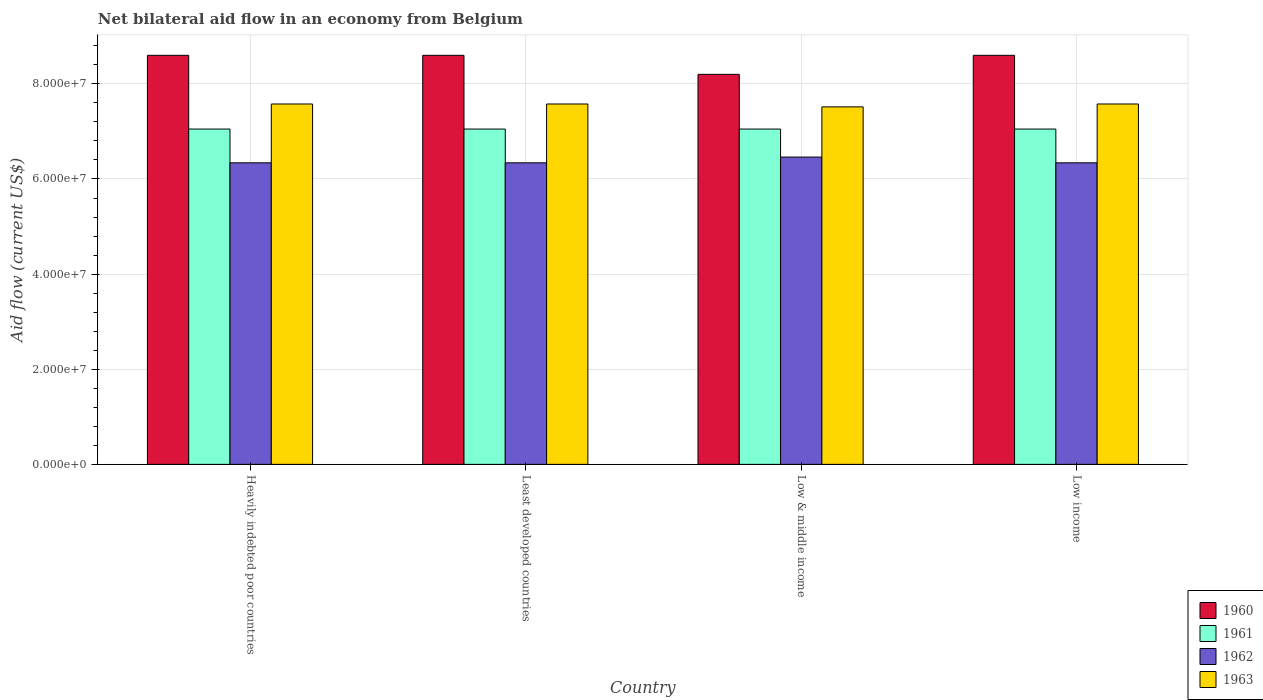How many groups of bars are there?
Keep it short and to the point. 4. Are the number of bars on each tick of the X-axis equal?
Provide a short and direct response. Yes. How many bars are there on the 1st tick from the right?
Provide a succinct answer. 4. What is the label of the 2nd group of bars from the left?
Provide a succinct answer. Least developed countries. What is the net bilateral aid flow in 1962 in Heavily indebted poor countries?
Offer a terse response. 6.34e+07. Across all countries, what is the maximum net bilateral aid flow in 1960?
Your answer should be very brief. 8.60e+07. Across all countries, what is the minimum net bilateral aid flow in 1963?
Make the answer very short. 7.52e+07. In which country was the net bilateral aid flow in 1963 minimum?
Provide a succinct answer. Low & middle income. What is the total net bilateral aid flow in 1962 in the graph?
Offer a very short reply. 2.55e+08. What is the difference between the net bilateral aid flow in 1961 in Low income and the net bilateral aid flow in 1963 in Least developed countries?
Provide a short and direct response. -5.27e+06. What is the average net bilateral aid flow in 1962 per country?
Offer a very short reply. 6.37e+07. What is the difference between the net bilateral aid flow of/in 1962 and net bilateral aid flow of/in 1960 in Low & middle income?
Give a very brief answer. -1.74e+07. Is the net bilateral aid flow in 1963 in Heavily indebted poor countries less than that in Low & middle income?
Offer a very short reply. No. Is the difference between the net bilateral aid flow in 1962 in Low & middle income and Low income greater than the difference between the net bilateral aid flow in 1960 in Low & middle income and Low income?
Offer a very short reply. Yes. What is the difference between the highest and the second highest net bilateral aid flow in 1962?
Your answer should be compact. 1.21e+06. Is it the case that in every country, the sum of the net bilateral aid flow in 1961 and net bilateral aid flow in 1962 is greater than the sum of net bilateral aid flow in 1963 and net bilateral aid flow in 1960?
Provide a succinct answer. No. What does the 2nd bar from the right in Heavily indebted poor countries represents?
Offer a terse response. 1962. Is it the case that in every country, the sum of the net bilateral aid flow in 1960 and net bilateral aid flow in 1961 is greater than the net bilateral aid flow in 1962?
Your response must be concise. Yes. Are all the bars in the graph horizontal?
Your response must be concise. No. Are the values on the major ticks of Y-axis written in scientific E-notation?
Your answer should be very brief. Yes. Does the graph contain grids?
Offer a terse response. Yes. How are the legend labels stacked?
Give a very brief answer. Vertical. What is the title of the graph?
Keep it short and to the point. Net bilateral aid flow in an economy from Belgium. Does "1977" appear as one of the legend labels in the graph?
Provide a short and direct response. No. What is the label or title of the Y-axis?
Provide a short and direct response. Aid flow (current US$). What is the Aid flow (current US$) in 1960 in Heavily indebted poor countries?
Your answer should be very brief. 8.60e+07. What is the Aid flow (current US$) in 1961 in Heavily indebted poor countries?
Give a very brief answer. 7.05e+07. What is the Aid flow (current US$) of 1962 in Heavily indebted poor countries?
Give a very brief answer. 6.34e+07. What is the Aid flow (current US$) in 1963 in Heavily indebted poor countries?
Your answer should be compact. 7.58e+07. What is the Aid flow (current US$) of 1960 in Least developed countries?
Give a very brief answer. 8.60e+07. What is the Aid flow (current US$) in 1961 in Least developed countries?
Provide a succinct answer. 7.05e+07. What is the Aid flow (current US$) in 1962 in Least developed countries?
Keep it short and to the point. 6.34e+07. What is the Aid flow (current US$) in 1963 in Least developed countries?
Ensure brevity in your answer.  7.58e+07. What is the Aid flow (current US$) in 1960 in Low & middle income?
Provide a short and direct response. 8.20e+07. What is the Aid flow (current US$) of 1961 in Low & middle income?
Ensure brevity in your answer.  7.05e+07. What is the Aid flow (current US$) in 1962 in Low & middle income?
Give a very brief answer. 6.46e+07. What is the Aid flow (current US$) of 1963 in Low & middle income?
Provide a short and direct response. 7.52e+07. What is the Aid flow (current US$) of 1960 in Low income?
Your answer should be compact. 8.60e+07. What is the Aid flow (current US$) in 1961 in Low income?
Make the answer very short. 7.05e+07. What is the Aid flow (current US$) in 1962 in Low income?
Provide a succinct answer. 6.34e+07. What is the Aid flow (current US$) of 1963 in Low income?
Ensure brevity in your answer.  7.58e+07. Across all countries, what is the maximum Aid flow (current US$) in 1960?
Your answer should be very brief. 8.60e+07. Across all countries, what is the maximum Aid flow (current US$) of 1961?
Make the answer very short. 7.05e+07. Across all countries, what is the maximum Aid flow (current US$) in 1962?
Make the answer very short. 6.46e+07. Across all countries, what is the maximum Aid flow (current US$) in 1963?
Give a very brief answer. 7.58e+07. Across all countries, what is the minimum Aid flow (current US$) in 1960?
Your answer should be compact. 8.20e+07. Across all countries, what is the minimum Aid flow (current US$) of 1961?
Keep it short and to the point. 7.05e+07. Across all countries, what is the minimum Aid flow (current US$) of 1962?
Your answer should be very brief. 6.34e+07. Across all countries, what is the minimum Aid flow (current US$) of 1963?
Your response must be concise. 7.52e+07. What is the total Aid flow (current US$) of 1960 in the graph?
Your response must be concise. 3.40e+08. What is the total Aid flow (current US$) in 1961 in the graph?
Make the answer very short. 2.82e+08. What is the total Aid flow (current US$) of 1962 in the graph?
Give a very brief answer. 2.55e+08. What is the total Aid flow (current US$) in 1963 in the graph?
Ensure brevity in your answer.  3.02e+08. What is the difference between the Aid flow (current US$) in 1961 in Heavily indebted poor countries and that in Least developed countries?
Provide a succinct answer. 0. What is the difference between the Aid flow (current US$) of 1962 in Heavily indebted poor countries and that in Least developed countries?
Your answer should be compact. 0. What is the difference between the Aid flow (current US$) in 1960 in Heavily indebted poor countries and that in Low & middle income?
Ensure brevity in your answer.  4.00e+06. What is the difference between the Aid flow (current US$) in 1962 in Heavily indebted poor countries and that in Low & middle income?
Give a very brief answer. -1.21e+06. What is the difference between the Aid flow (current US$) of 1963 in Heavily indebted poor countries and that in Low & middle income?
Keep it short and to the point. 6.10e+05. What is the difference between the Aid flow (current US$) in 1960 in Heavily indebted poor countries and that in Low income?
Provide a short and direct response. 0. What is the difference between the Aid flow (current US$) of 1963 in Heavily indebted poor countries and that in Low income?
Keep it short and to the point. 0. What is the difference between the Aid flow (current US$) of 1960 in Least developed countries and that in Low & middle income?
Keep it short and to the point. 4.00e+06. What is the difference between the Aid flow (current US$) of 1961 in Least developed countries and that in Low & middle income?
Give a very brief answer. 0. What is the difference between the Aid flow (current US$) of 1962 in Least developed countries and that in Low & middle income?
Offer a terse response. -1.21e+06. What is the difference between the Aid flow (current US$) in 1963 in Least developed countries and that in Low & middle income?
Keep it short and to the point. 6.10e+05. What is the difference between the Aid flow (current US$) in 1962 in Least developed countries and that in Low income?
Your response must be concise. 0. What is the difference between the Aid flow (current US$) in 1961 in Low & middle income and that in Low income?
Keep it short and to the point. 0. What is the difference between the Aid flow (current US$) in 1962 in Low & middle income and that in Low income?
Offer a terse response. 1.21e+06. What is the difference between the Aid flow (current US$) of 1963 in Low & middle income and that in Low income?
Keep it short and to the point. -6.10e+05. What is the difference between the Aid flow (current US$) of 1960 in Heavily indebted poor countries and the Aid flow (current US$) of 1961 in Least developed countries?
Provide a short and direct response. 1.55e+07. What is the difference between the Aid flow (current US$) in 1960 in Heavily indebted poor countries and the Aid flow (current US$) in 1962 in Least developed countries?
Provide a short and direct response. 2.26e+07. What is the difference between the Aid flow (current US$) in 1960 in Heavily indebted poor countries and the Aid flow (current US$) in 1963 in Least developed countries?
Your response must be concise. 1.02e+07. What is the difference between the Aid flow (current US$) in 1961 in Heavily indebted poor countries and the Aid flow (current US$) in 1962 in Least developed countries?
Make the answer very short. 7.10e+06. What is the difference between the Aid flow (current US$) of 1961 in Heavily indebted poor countries and the Aid flow (current US$) of 1963 in Least developed countries?
Provide a succinct answer. -5.27e+06. What is the difference between the Aid flow (current US$) of 1962 in Heavily indebted poor countries and the Aid flow (current US$) of 1963 in Least developed countries?
Provide a short and direct response. -1.24e+07. What is the difference between the Aid flow (current US$) of 1960 in Heavily indebted poor countries and the Aid flow (current US$) of 1961 in Low & middle income?
Offer a very short reply. 1.55e+07. What is the difference between the Aid flow (current US$) in 1960 in Heavily indebted poor countries and the Aid flow (current US$) in 1962 in Low & middle income?
Make the answer very short. 2.14e+07. What is the difference between the Aid flow (current US$) of 1960 in Heavily indebted poor countries and the Aid flow (current US$) of 1963 in Low & middle income?
Provide a short and direct response. 1.08e+07. What is the difference between the Aid flow (current US$) of 1961 in Heavily indebted poor countries and the Aid flow (current US$) of 1962 in Low & middle income?
Make the answer very short. 5.89e+06. What is the difference between the Aid flow (current US$) of 1961 in Heavily indebted poor countries and the Aid flow (current US$) of 1963 in Low & middle income?
Make the answer very short. -4.66e+06. What is the difference between the Aid flow (current US$) in 1962 in Heavily indebted poor countries and the Aid flow (current US$) in 1963 in Low & middle income?
Provide a succinct answer. -1.18e+07. What is the difference between the Aid flow (current US$) of 1960 in Heavily indebted poor countries and the Aid flow (current US$) of 1961 in Low income?
Keep it short and to the point. 1.55e+07. What is the difference between the Aid flow (current US$) of 1960 in Heavily indebted poor countries and the Aid flow (current US$) of 1962 in Low income?
Your answer should be very brief. 2.26e+07. What is the difference between the Aid flow (current US$) in 1960 in Heavily indebted poor countries and the Aid flow (current US$) in 1963 in Low income?
Your response must be concise. 1.02e+07. What is the difference between the Aid flow (current US$) in 1961 in Heavily indebted poor countries and the Aid flow (current US$) in 1962 in Low income?
Ensure brevity in your answer.  7.10e+06. What is the difference between the Aid flow (current US$) of 1961 in Heavily indebted poor countries and the Aid flow (current US$) of 1963 in Low income?
Provide a succinct answer. -5.27e+06. What is the difference between the Aid flow (current US$) in 1962 in Heavily indebted poor countries and the Aid flow (current US$) in 1963 in Low income?
Provide a succinct answer. -1.24e+07. What is the difference between the Aid flow (current US$) of 1960 in Least developed countries and the Aid flow (current US$) of 1961 in Low & middle income?
Keep it short and to the point. 1.55e+07. What is the difference between the Aid flow (current US$) of 1960 in Least developed countries and the Aid flow (current US$) of 1962 in Low & middle income?
Offer a terse response. 2.14e+07. What is the difference between the Aid flow (current US$) of 1960 in Least developed countries and the Aid flow (current US$) of 1963 in Low & middle income?
Offer a very short reply. 1.08e+07. What is the difference between the Aid flow (current US$) of 1961 in Least developed countries and the Aid flow (current US$) of 1962 in Low & middle income?
Keep it short and to the point. 5.89e+06. What is the difference between the Aid flow (current US$) of 1961 in Least developed countries and the Aid flow (current US$) of 1963 in Low & middle income?
Give a very brief answer. -4.66e+06. What is the difference between the Aid flow (current US$) in 1962 in Least developed countries and the Aid flow (current US$) in 1963 in Low & middle income?
Provide a short and direct response. -1.18e+07. What is the difference between the Aid flow (current US$) of 1960 in Least developed countries and the Aid flow (current US$) of 1961 in Low income?
Offer a very short reply. 1.55e+07. What is the difference between the Aid flow (current US$) of 1960 in Least developed countries and the Aid flow (current US$) of 1962 in Low income?
Your answer should be very brief. 2.26e+07. What is the difference between the Aid flow (current US$) of 1960 in Least developed countries and the Aid flow (current US$) of 1963 in Low income?
Offer a terse response. 1.02e+07. What is the difference between the Aid flow (current US$) in 1961 in Least developed countries and the Aid flow (current US$) in 1962 in Low income?
Keep it short and to the point. 7.10e+06. What is the difference between the Aid flow (current US$) in 1961 in Least developed countries and the Aid flow (current US$) in 1963 in Low income?
Ensure brevity in your answer.  -5.27e+06. What is the difference between the Aid flow (current US$) in 1962 in Least developed countries and the Aid flow (current US$) in 1963 in Low income?
Offer a terse response. -1.24e+07. What is the difference between the Aid flow (current US$) in 1960 in Low & middle income and the Aid flow (current US$) in 1961 in Low income?
Provide a short and direct response. 1.15e+07. What is the difference between the Aid flow (current US$) in 1960 in Low & middle income and the Aid flow (current US$) in 1962 in Low income?
Give a very brief answer. 1.86e+07. What is the difference between the Aid flow (current US$) of 1960 in Low & middle income and the Aid flow (current US$) of 1963 in Low income?
Keep it short and to the point. 6.23e+06. What is the difference between the Aid flow (current US$) in 1961 in Low & middle income and the Aid flow (current US$) in 1962 in Low income?
Provide a short and direct response. 7.10e+06. What is the difference between the Aid flow (current US$) in 1961 in Low & middle income and the Aid flow (current US$) in 1963 in Low income?
Your answer should be very brief. -5.27e+06. What is the difference between the Aid flow (current US$) of 1962 in Low & middle income and the Aid flow (current US$) of 1963 in Low income?
Offer a very short reply. -1.12e+07. What is the average Aid flow (current US$) in 1960 per country?
Provide a succinct answer. 8.50e+07. What is the average Aid flow (current US$) of 1961 per country?
Your answer should be compact. 7.05e+07. What is the average Aid flow (current US$) of 1962 per country?
Provide a succinct answer. 6.37e+07. What is the average Aid flow (current US$) in 1963 per country?
Your response must be concise. 7.56e+07. What is the difference between the Aid flow (current US$) in 1960 and Aid flow (current US$) in 1961 in Heavily indebted poor countries?
Keep it short and to the point. 1.55e+07. What is the difference between the Aid flow (current US$) in 1960 and Aid flow (current US$) in 1962 in Heavily indebted poor countries?
Your answer should be compact. 2.26e+07. What is the difference between the Aid flow (current US$) of 1960 and Aid flow (current US$) of 1963 in Heavily indebted poor countries?
Your answer should be compact. 1.02e+07. What is the difference between the Aid flow (current US$) of 1961 and Aid flow (current US$) of 1962 in Heavily indebted poor countries?
Offer a terse response. 7.10e+06. What is the difference between the Aid flow (current US$) in 1961 and Aid flow (current US$) in 1963 in Heavily indebted poor countries?
Make the answer very short. -5.27e+06. What is the difference between the Aid flow (current US$) in 1962 and Aid flow (current US$) in 1963 in Heavily indebted poor countries?
Offer a terse response. -1.24e+07. What is the difference between the Aid flow (current US$) of 1960 and Aid flow (current US$) of 1961 in Least developed countries?
Keep it short and to the point. 1.55e+07. What is the difference between the Aid flow (current US$) in 1960 and Aid flow (current US$) in 1962 in Least developed countries?
Your answer should be compact. 2.26e+07. What is the difference between the Aid flow (current US$) of 1960 and Aid flow (current US$) of 1963 in Least developed countries?
Offer a very short reply. 1.02e+07. What is the difference between the Aid flow (current US$) of 1961 and Aid flow (current US$) of 1962 in Least developed countries?
Offer a very short reply. 7.10e+06. What is the difference between the Aid flow (current US$) in 1961 and Aid flow (current US$) in 1963 in Least developed countries?
Keep it short and to the point. -5.27e+06. What is the difference between the Aid flow (current US$) of 1962 and Aid flow (current US$) of 1963 in Least developed countries?
Offer a terse response. -1.24e+07. What is the difference between the Aid flow (current US$) in 1960 and Aid flow (current US$) in 1961 in Low & middle income?
Ensure brevity in your answer.  1.15e+07. What is the difference between the Aid flow (current US$) in 1960 and Aid flow (current US$) in 1962 in Low & middle income?
Offer a terse response. 1.74e+07. What is the difference between the Aid flow (current US$) in 1960 and Aid flow (current US$) in 1963 in Low & middle income?
Keep it short and to the point. 6.84e+06. What is the difference between the Aid flow (current US$) of 1961 and Aid flow (current US$) of 1962 in Low & middle income?
Provide a succinct answer. 5.89e+06. What is the difference between the Aid flow (current US$) of 1961 and Aid flow (current US$) of 1963 in Low & middle income?
Ensure brevity in your answer.  -4.66e+06. What is the difference between the Aid flow (current US$) of 1962 and Aid flow (current US$) of 1963 in Low & middle income?
Your answer should be compact. -1.06e+07. What is the difference between the Aid flow (current US$) of 1960 and Aid flow (current US$) of 1961 in Low income?
Keep it short and to the point. 1.55e+07. What is the difference between the Aid flow (current US$) in 1960 and Aid flow (current US$) in 1962 in Low income?
Give a very brief answer. 2.26e+07. What is the difference between the Aid flow (current US$) of 1960 and Aid flow (current US$) of 1963 in Low income?
Ensure brevity in your answer.  1.02e+07. What is the difference between the Aid flow (current US$) in 1961 and Aid flow (current US$) in 1962 in Low income?
Your answer should be compact. 7.10e+06. What is the difference between the Aid flow (current US$) in 1961 and Aid flow (current US$) in 1963 in Low income?
Provide a succinct answer. -5.27e+06. What is the difference between the Aid flow (current US$) in 1962 and Aid flow (current US$) in 1963 in Low income?
Ensure brevity in your answer.  -1.24e+07. What is the ratio of the Aid flow (current US$) in 1962 in Heavily indebted poor countries to that in Least developed countries?
Keep it short and to the point. 1. What is the ratio of the Aid flow (current US$) of 1960 in Heavily indebted poor countries to that in Low & middle income?
Provide a short and direct response. 1.05. What is the ratio of the Aid flow (current US$) of 1962 in Heavily indebted poor countries to that in Low & middle income?
Ensure brevity in your answer.  0.98. What is the ratio of the Aid flow (current US$) in 1963 in Heavily indebted poor countries to that in Low & middle income?
Provide a succinct answer. 1.01. What is the ratio of the Aid flow (current US$) in 1960 in Heavily indebted poor countries to that in Low income?
Your answer should be very brief. 1. What is the ratio of the Aid flow (current US$) of 1963 in Heavily indebted poor countries to that in Low income?
Your answer should be compact. 1. What is the ratio of the Aid flow (current US$) of 1960 in Least developed countries to that in Low & middle income?
Give a very brief answer. 1.05. What is the ratio of the Aid flow (current US$) of 1961 in Least developed countries to that in Low & middle income?
Your answer should be very brief. 1. What is the ratio of the Aid flow (current US$) of 1962 in Least developed countries to that in Low & middle income?
Provide a succinct answer. 0.98. What is the ratio of the Aid flow (current US$) of 1960 in Low & middle income to that in Low income?
Your answer should be compact. 0.95. What is the ratio of the Aid flow (current US$) in 1961 in Low & middle income to that in Low income?
Keep it short and to the point. 1. What is the ratio of the Aid flow (current US$) of 1962 in Low & middle income to that in Low income?
Provide a succinct answer. 1.02. What is the ratio of the Aid flow (current US$) in 1963 in Low & middle income to that in Low income?
Give a very brief answer. 0.99. What is the difference between the highest and the second highest Aid flow (current US$) of 1962?
Give a very brief answer. 1.21e+06. What is the difference between the highest and the lowest Aid flow (current US$) of 1961?
Make the answer very short. 0. What is the difference between the highest and the lowest Aid flow (current US$) in 1962?
Offer a very short reply. 1.21e+06. 